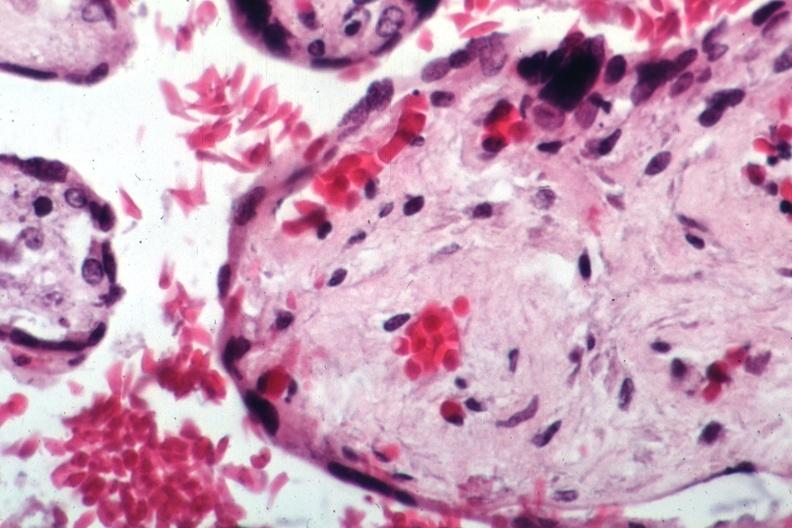what is present?
Answer the question using a single word or phrase. Placenta 